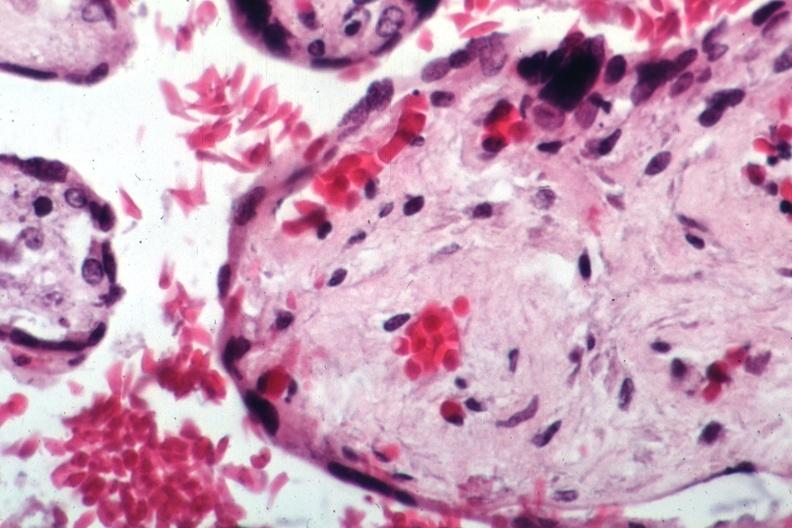what is present?
Answer the question using a single word or phrase. Placenta 